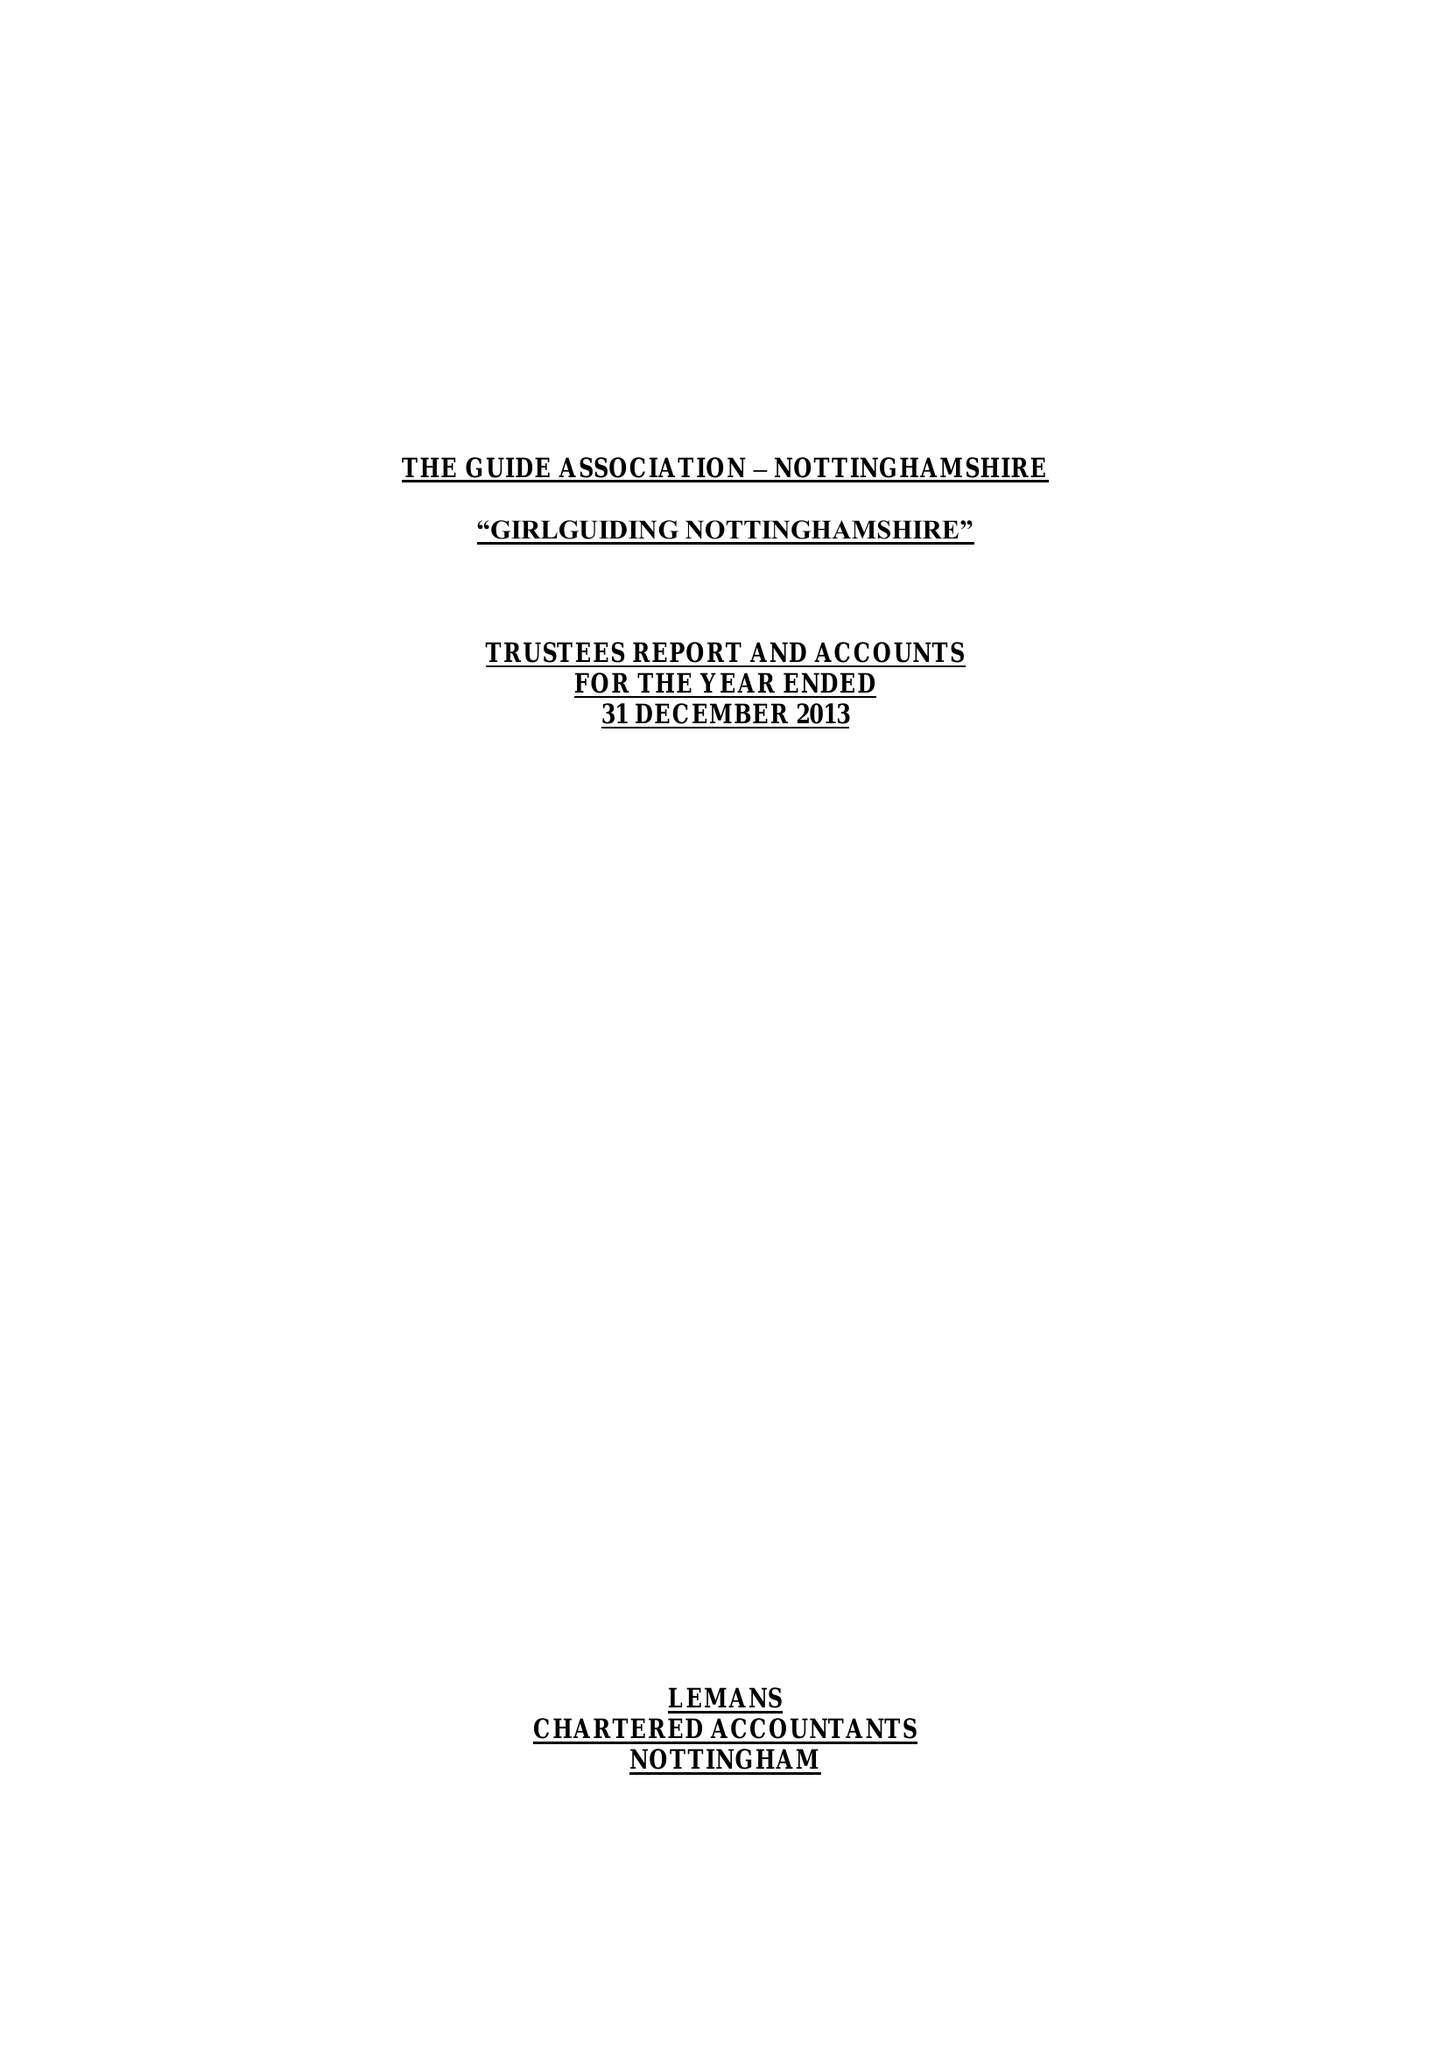What is the value for the charity_name?
Answer the question using a single word or phrase. The Guide Association - Nottinghamshire County 